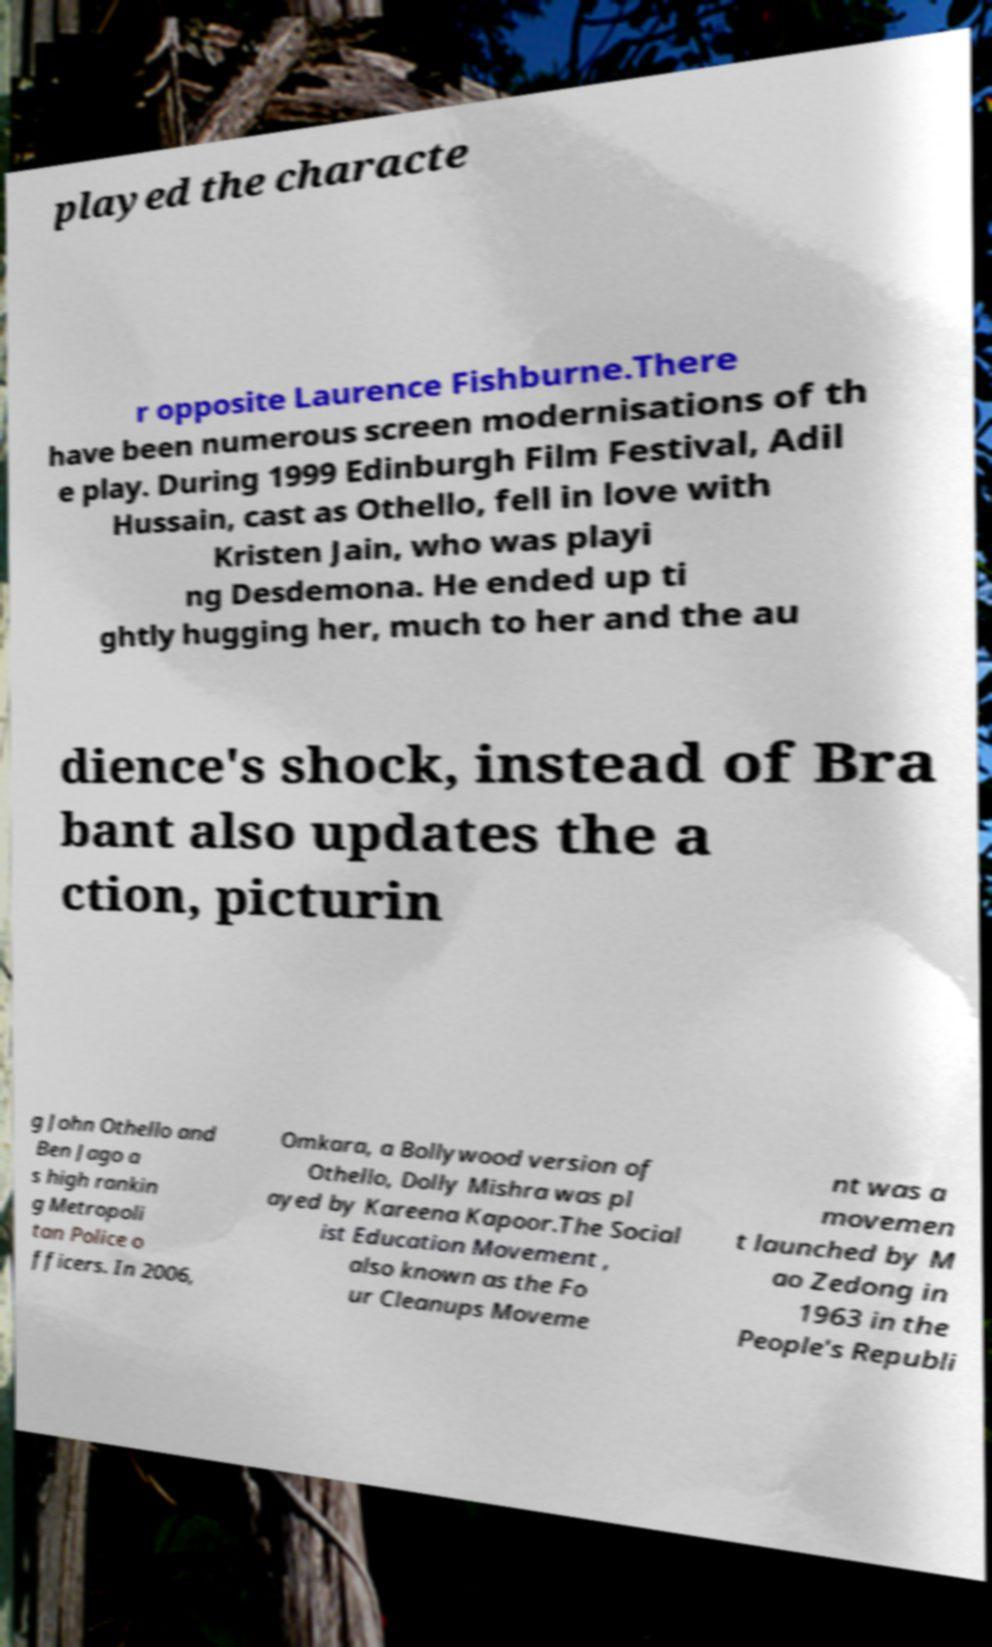Could you assist in decoding the text presented in this image and type it out clearly? played the characte r opposite Laurence Fishburne.There have been numerous screen modernisations of th e play. During 1999 Edinburgh Film Festival, Adil Hussain, cast as Othello, fell in love with Kristen Jain, who was playi ng Desdemona. He ended up ti ghtly hugging her, much to her and the au dience's shock, instead of Bra bant also updates the a ction, picturin g John Othello and Ben Jago a s high rankin g Metropoli tan Police o fficers. In 2006, Omkara, a Bollywood version of Othello, Dolly Mishra was pl ayed by Kareena Kapoor.The Social ist Education Movement , also known as the Fo ur Cleanups Moveme nt was a movemen t launched by M ao Zedong in 1963 in the People's Republi 